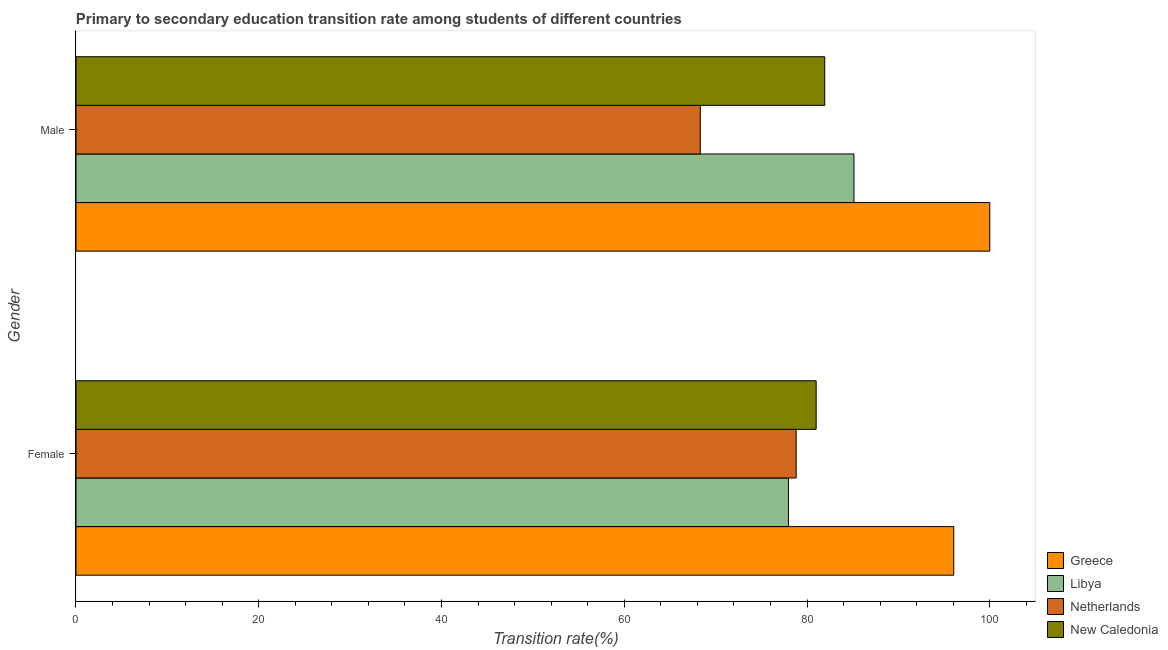How many different coloured bars are there?
Your answer should be compact. 4. How many groups of bars are there?
Keep it short and to the point. 2. Are the number of bars per tick equal to the number of legend labels?
Provide a short and direct response. Yes. Are the number of bars on each tick of the Y-axis equal?
Offer a terse response. Yes. How many bars are there on the 1st tick from the top?
Your answer should be very brief. 4. How many bars are there on the 1st tick from the bottom?
Your response must be concise. 4. What is the transition rate among female students in Netherlands?
Your answer should be compact. 78.81. Across all countries, what is the maximum transition rate among male students?
Offer a very short reply. 100. Across all countries, what is the minimum transition rate among female students?
Ensure brevity in your answer.  77.96. In which country was the transition rate among male students maximum?
Provide a short and direct response. Greece. In which country was the transition rate among female students minimum?
Offer a terse response. Libya. What is the total transition rate among male students in the graph?
Keep it short and to the point. 335.39. What is the difference between the transition rate among male students in New Caledonia and that in Netherlands?
Make the answer very short. 13.62. What is the difference between the transition rate among female students in Libya and the transition rate among male students in Greece?
Offer a terse response. -22.04. What is the average transition rate among male students per country?
Offer a very short reply. 83.85. What is the difference between the transition rate among female students and transition rate among male students in Netherlands?
Give a very brief answer. 10.49. In how many countries, is the transition rate among female students greater than 20 %?
Your response must be concise. 4. What is the ratio of the transition rate among female students in Greece to that in Libya?
Provide a succinct answer. 1.23. In how many countries, is the transition rate among male students greater than the average transition rate among male students taken over all countries?
Provide a short and direct response. 2. What does the 3rd bar from the top in Male represents?
Give a very brief answer. Libya. What does the 2nd bar from the bottom in Male represents?
Provide a short and direct response. Libya. Are the values on the major ticks of X-axis written in scientific E-notation?
Ensure brevity in your answer.  No. Does the graph contain any zero values?
Your response must be concise. No. Does the graph contain grids?
Your answer should be very brief. No. How are the legend labels stacked?
Make the answer very short. Vertical. What is the title of the graph?
Offer a terse response. Primary to secondary education transition rate among students of different countries. What is the label or title of the X-axis?
Make the answer very short. Transition rate(%). What is the label or title of the Y-axis?
Ensure brevity in your answer.  Gender. What is the Transition rate(%) of Greece in Female?
Keep it short and to the point. 96.06. What is the Transition rate(%) in Libya in Female?
Offer a terse response. 77.96. What is the Transition rate(%) in Netherlands in Female?
Provide a short and direct response. 78.81. What is the Transition rate(%) of New Caledonia in Female?
Keep it short and to the point. 81. What is the Transition rate(%) in Greece in Male?
Give a very brief answer. 100. What is the Transition rate(%) in Libya in Male?
Ensure brevity in your answer.  85.14. What is the Transition rate(%) of Netherlands in Male?
Give a very brief answer. 68.32. What is the Transition rate(%) in New Caledonia in Male?
Give a very brief answer. 81.94. Across all Gender, what is the maximum Transition rate(%) in Libya?
Ensure brevity in your answer.  85.14. Across all Gender, what is the maximum Transition rate(%) in Netherlands?
Offer a terse response. 78.81. Across all Gender, what is the maximum Transition rate(%) in New Caledonia?
Offer a terse response. 81.94. Across all Gender, what is the minimum Transition rate(%) of Greece?
Make the answer very short. 96.06. Across all Gender, what is the minimum Transition rate(%) of Libya?
Give a very brief answer. 77.96. Across all Gender, what is the minimum Transition rate(%) of Netherlands?
Your response must be concise. 68.32. Across all Gender, what is the minimum Transition rate(%) in New Caledonia?
Your answer should be compact. 81. What is the total Transition rate(%) in Greece in the graph?
Give a very brief answer. 196.06. What is the total Transition rate(%) of Libya in the graph?
Offer a terse response. 163.1. What is the total Transition rate(%) of Netherlands in the graph?
Provide a succinct answer. 147.13. What is the total Transition rate(%) in New Caledonia in the graph?
Keep it short and to the point. 162.94. What is the difference between the Transition rate(%) of Greece in Female and that in Male?
Make the answer very short. -3.94. What is the difference between the Transition rate(%) in Libya in Female and that in Male?
Keep it short and to the point. -7.17. What is the difference between the Transition rate(%) of Netherlands in Female and that in Male?
Provide a short and direct response. 10.49. What is the difference between the Transition rate(%) of New Caledonia in Female and that in Male?
Your answer should be very brief. -0.94. What is the difference between the Transition rate(%) of Greece in Female and the Transition rate(%) of Libya in Male?
Provide a short and direct response. 10.92. What is the difference between the Transition rate(%) of Greece in Female and the Transition rate(%) of Netherlands in Male?
Give a very brief answer. 27.74. What is the difference between the Transition rate(%) of Greece in Female and the Transition rate(%) of New Caledonia in Male?
Offer a terse response. 14.12. What is the difference between the Transition rate(%) in Libya in Female and the Transition rate(%) in Netherlands in Male?
Provide a succinct answer. 9.65. What is the difference between the Transition rate(%) of Libya in Female and the Transition rate(%) of New Caledonia in Male?
Your response must be concise. -3.97. What is the difference between the Transition rate(%) in Netherlands in Female and the Transition rate(%) in New Caledonia in Male?
Keep it short and to the point. -3.13. What is the average Transition rate(%) of Greece per Gender?
Offer a very short reply. 98.03. What is the average Transition rate(%) in Libya per Gender?
Give a very brief answer. 81.55. What is the average Transition rate(%) in Netherlands per Gender?
Keep it short and to the point. 73.57. What is the average Transition rate(%) in New Caledonia per Gender?
Provide a succinct answer. 81.47. What is the difference between the Transition rate(%) in Greece and Transition rate(%) in Libya in Female?
Ensure brevity in your answer.  18.09. What is the difference between the Transition rate(%) in Greece and Transition rate(%) in Netherlands in Female?
Your response must be concise. 17.25. What is the difference between the Transition rate(%) of Greece and Transition rate(%) of New Caledonia in Female?
Keep it short and to the point. 15.06. What is the difference between the Transition rate(%) in Libya and Transition rate(%) in Netherlands in Female?
Your answer should be very brief. -0.85. What is the difference between the Transition rate(%) of Libya and Transition rate(%) of New Caledonia in Female?
Offer a very short reply. -3.03. What is the difference between the Transition rate(%) in Netherlands and Transition rate(%) in New Caledonia in Female?
Your answer should be compact. -2.19. What is the difference between the Transition rate(%) of Greece and Transition rate(%) of Libya in Male?
Provide a succinct answer. 14.86. What is the difference between the Transition rate(%) in Greece and Transition rate(%) in Netherlands in Male?
Your answer should be very brief. 31.68. What is the difference between the Transition rate(%) of Greece and Transition rate(%) of New Caledonia in Male?
Your answer should be compact. 18.06. What is the difference between the Transition rate(%) in Libya and Transition rate(%) in Netherlands in Male?
Provide a succinct answer. 16.82. What is the difference between the Transition rate(%) in Libya and Transition rate(%) in New Caledonia in Male?
Your response must be concise. 3.2. What is the difference between the Transition rate(%) in Netherlands and Transition rate(%) in New Caledonia in Male?
Provide a short and direct response. -13.62. What is the ratio of the Transition rate(%) in Greece in Female to that in Male?
Provide a short and direct response. 0.96. What is the ratio of the Transition rate(%) in Libya in Female to that in Male?
Give a very brief answer. 0.92. What is the ratio of the Transition rate(%) in Netherlands in Female to that in Male?
Provide a short and direct response. 1.15. What is the ratio of the Transition rate(%) in New Caledonia in Female to that in Male?
Keep it short and to the point. 0.99. What is the difference between the highest and the second highest Transition rate(%) in Greece?
Your answer should be compact. 3.94. What is the difference between the highest and the second highest Transition rate(%) of Libya?
Provide a succinct answer. 7.17. What is the difference between the highest and the second highest Transition rate(%) of Netherlands?
Provide a succinct answer. 10.49. What is the difference between the highest and the second highest Transition rate(%) of New Caledonia?
Provide a short and direct response. 0.94. What is the difference between the highest and the lowest Transition rate(%) in Greece?
Give a very brief answer. 3.94. What is the difference between the highest and the lowest Transition rate(%) in Libya?
Offer a terse response. 7.17. What is the difference between the highest and the lowest Transition rate(%) of Netherlands?
Your answer should be very brief. 10.49. What is the difference between the highest and the lowest Transition rate(%) in New Caledonia?
Your response must be concise. 0.94. 